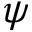<formula> <loc_0><loc_0><loc_500><loc_500>\psi</formula> 